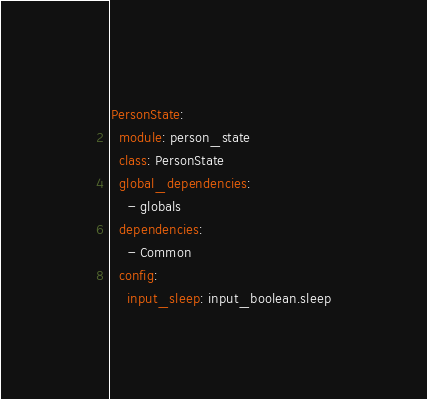<code> <loc_0><loc_0><loc_500><loc_500><_YAML_>PersonState:
  module: person_state
  class: PersonState
  global_dependencies:
    - globals
  dependencies:
    - Common
  config:
    input_sleep: input_boolean.sleep
</code> 